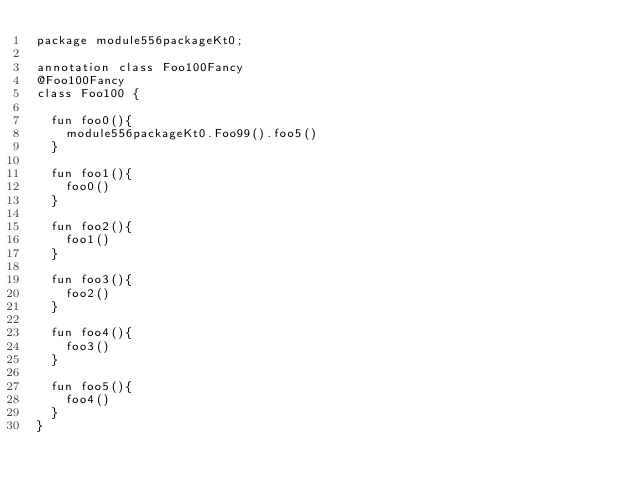Convert code to text. <code><loc_0><loc_0><loc_500><loc_500><_Kotlin_>package module556packageKt0;

annotation class Foo100Fancy
@Foo100Fancy
class Foo100 {

  fun foo0(){
    module556packageKt0.Foo99().foo5()
  }

  fun foo1(){
    foo0()
  }

  fun foo2(){
    foo1()
  }

  fun foo3(){
    foo2()
  }

  fun foo4(){
    foo3()
  }

  fun foo5(){
    foo4()
  }
}</code> 